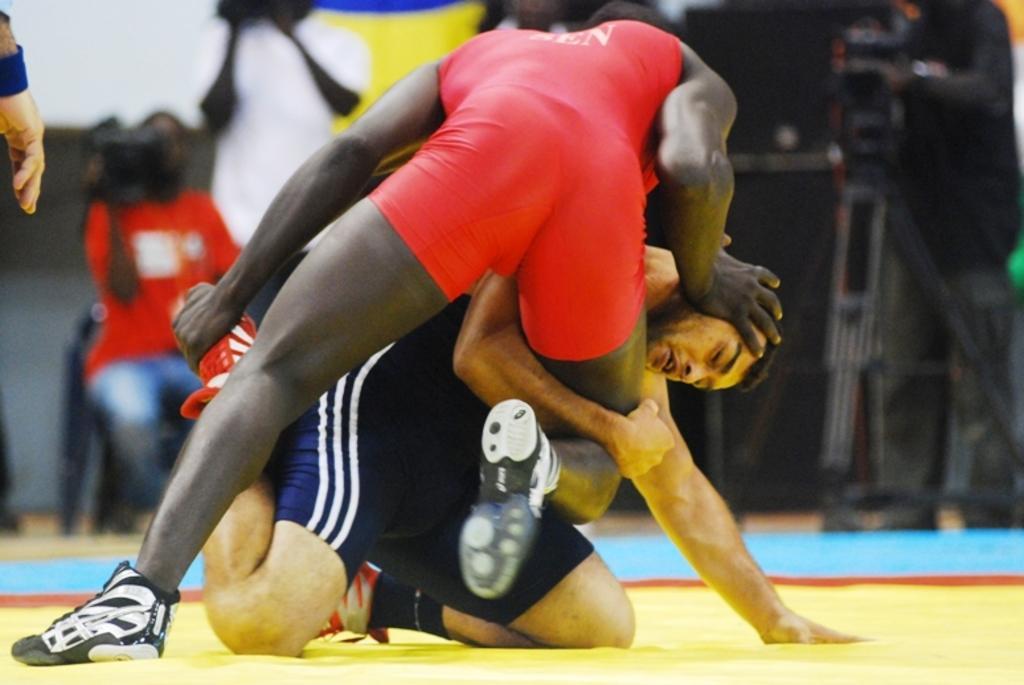Describe this image in one or two sentences. In this image I can see two persons playing game. The person in front wearing red color dress and the other person wearing blue color dress. Background I can see a person sitting and holding a camera and I can also see the other person standing. 